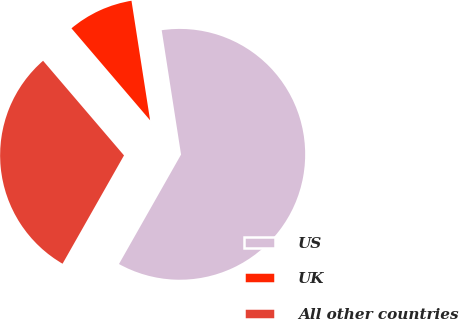Convert chart to OTSL. <chart><loc_0><loc_0><loc_500><loc_500><pie_chart><fcel>US<fcel>UK<fcel>All other countries<nl><fcel>60.67%<fcel>8.8%<fcel>30.53%<nl></chart> 